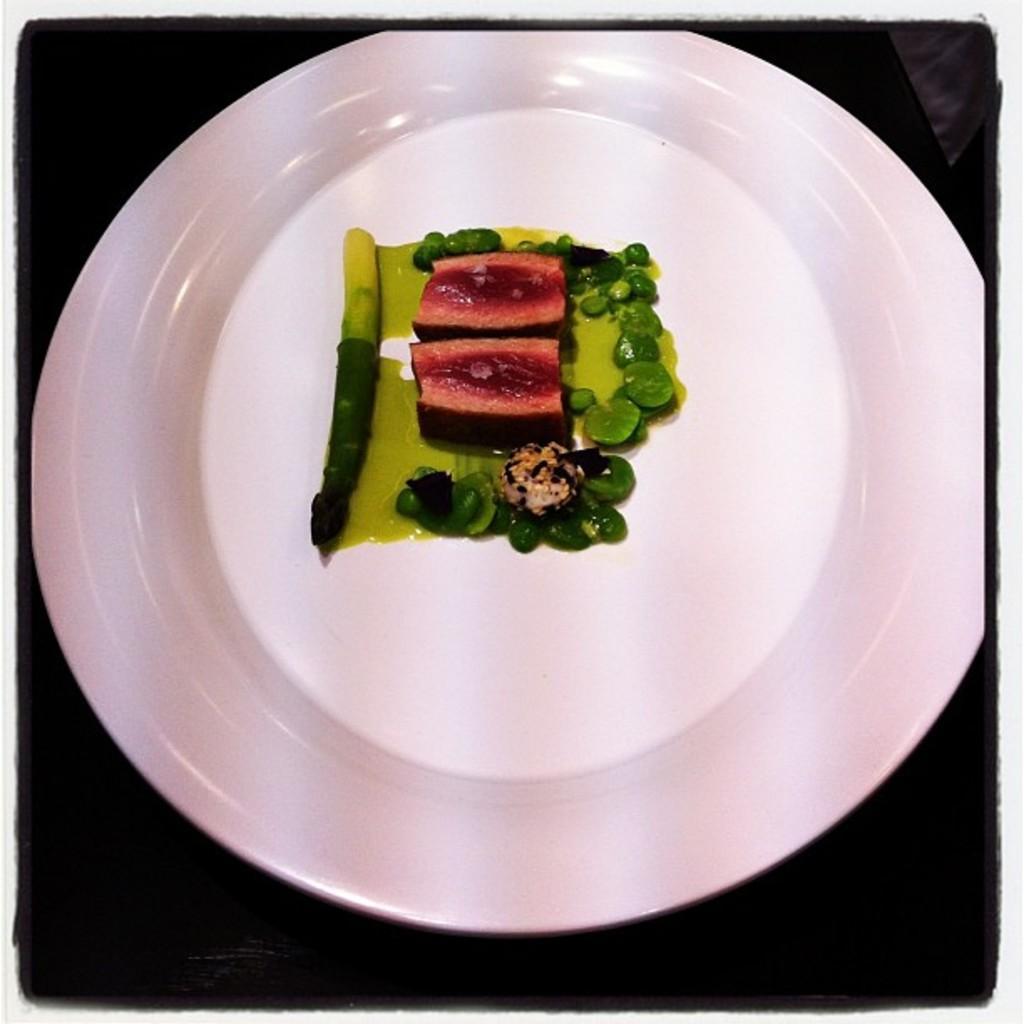Describe this image in one or two sentences. In the image there is a white plate. On the plate there is a green and red color food item. 